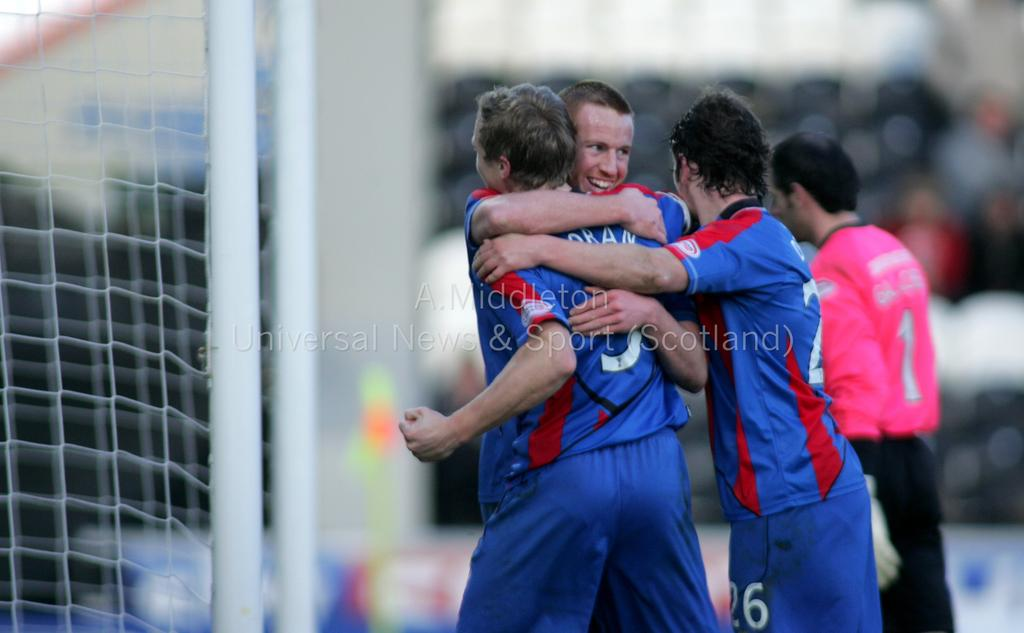<image>
Offer a succinct explanation of the picture presented. The person wearing the pink jersey is number 1 